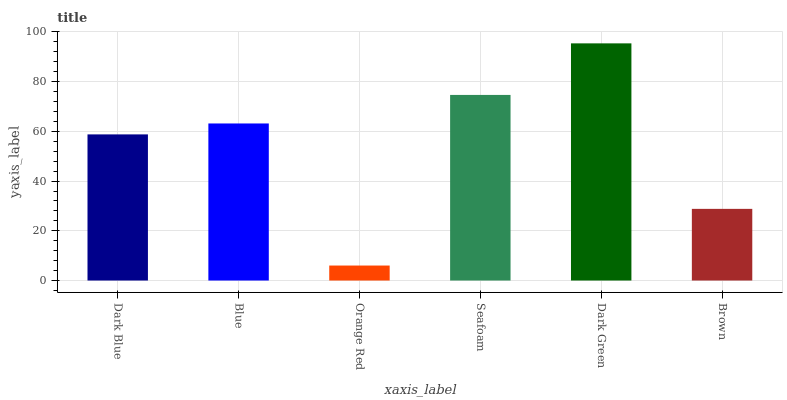Is Orange Red the minimum?
Answer yes or no. Yes. Is Dark Green the maximum?
Answer yes or no. Yes. Is Blue the minimum?
Answer yes or no. No. Is Blue the maximum?
Answer yes or no. No. Is Blue greater than Dark Blue?
Answer yes or no. Yes. Is Dark Blue less than Blue?
Answer yes or no. Yes. Is Dark Blue greater than Blue?
Answer yes or no. No. Is Blue less than Dark Blue?
Answer yes or no. No. Is Blue the high median?
Answer yes or no. Yes. Is Dark Blue the low median?
Answer yes or no. Yes. Is Brown the high median?
Answer yes or no. No. Is Seafoam the low median?
Answer yes or no. No. 